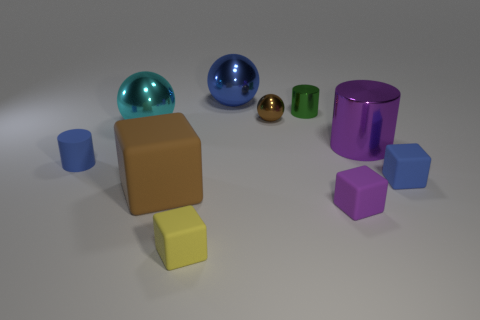What shape is the small blue rubber thing that is on the right side of the blue cylinder?
Your answer should be very brief. Cube. There is a small cube to the left of the tiny cylinder behind the large cylinder; what color is it?
Your answer should be very brief. Yellow. What number of objects are either balls that are behind the tiny brown object or small matte cylinders?
Offer a very short reply. 2. There is a brown shiny sphere; is it the same size as the object that is behind the green cylinder?
Your response must be concise. No. What number of large things are red shiny balls or rubber objects?
Your answer should be very brief. 1. There is a big purple object; what shape is it?
Provide a succinct answer. Cylinder. What size is the matte cube that is the same color as the big cylinder?
Your answer should be compact. Small. Is there a tiny blue cylinder made of the same material as the green thing?
Offer a very short reply. No. Is the number of small brown objects greater than the number of small purple shiny cylinders?
Make the answer very short. Yes. Are the tiny blue cylinder and the big cylinder made of the same material?
Give a very brief answer. No. 